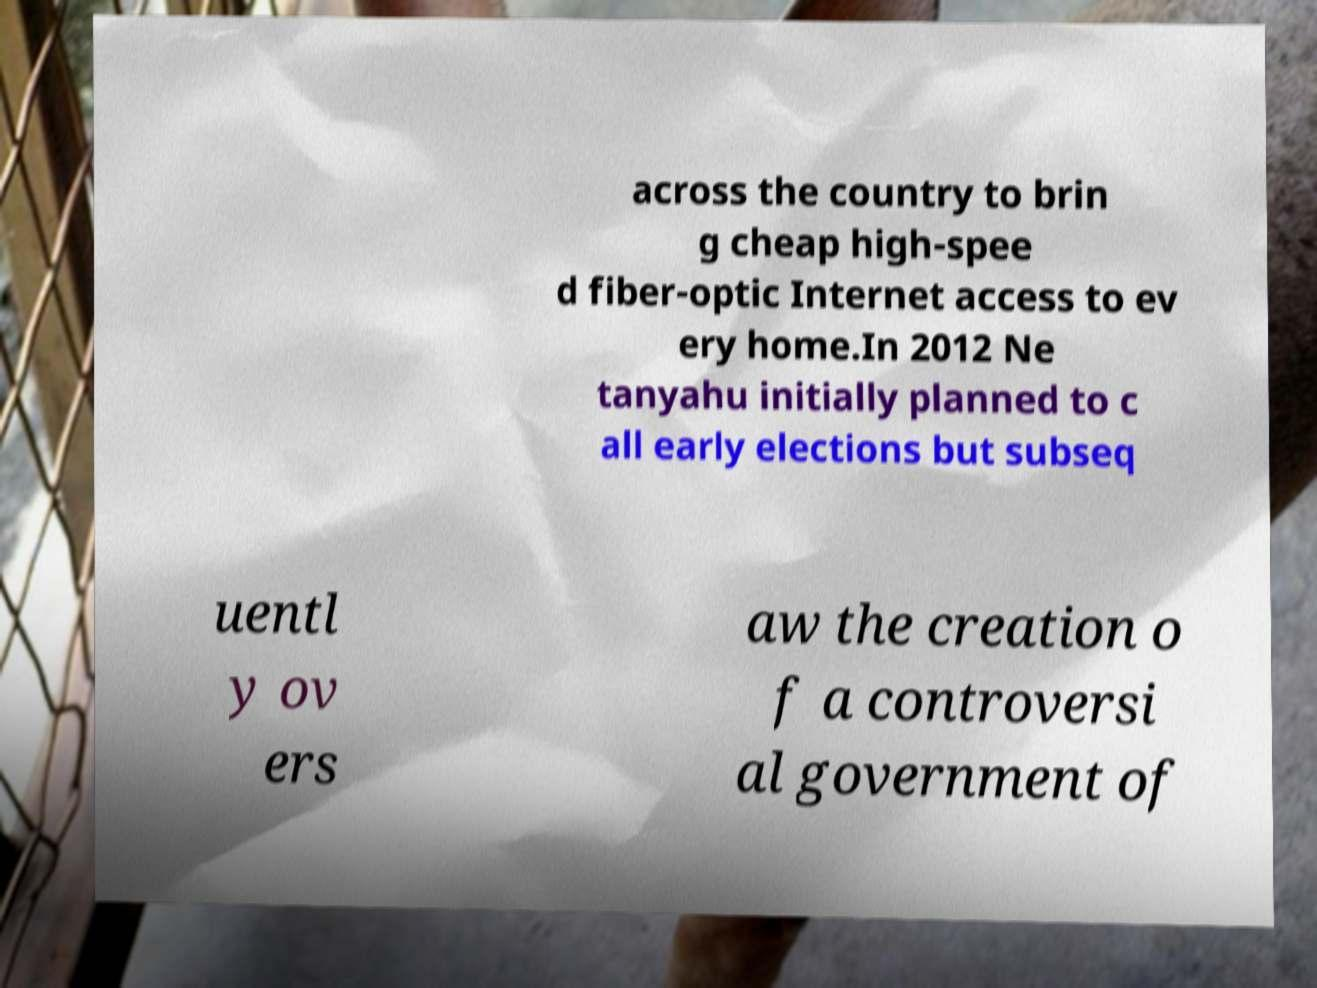What messages or text are displayed in this image? I need them in a readable, typed format. across the country to brin g cheap high-spee d fiber-optic Internet access to ev ery home.In 2012 Ne tanyahu initially planned to c all early elections but subseq uentl y ov ers aw the creation o f a controversi al government of 